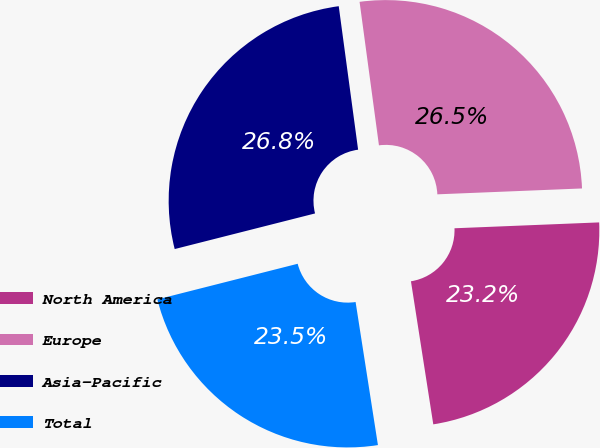Convert chart to OTSL. <chart><loc_0><loc_0><loc_500><loc_500><pie_chart><fcel>North America<fcel>Europe<fcel>Asia-Pacific<fcel>Total<nl><fcel>23.18%<fcel>26.49%<fcel>26.82%<fcel>23.51%<nl></chart> 